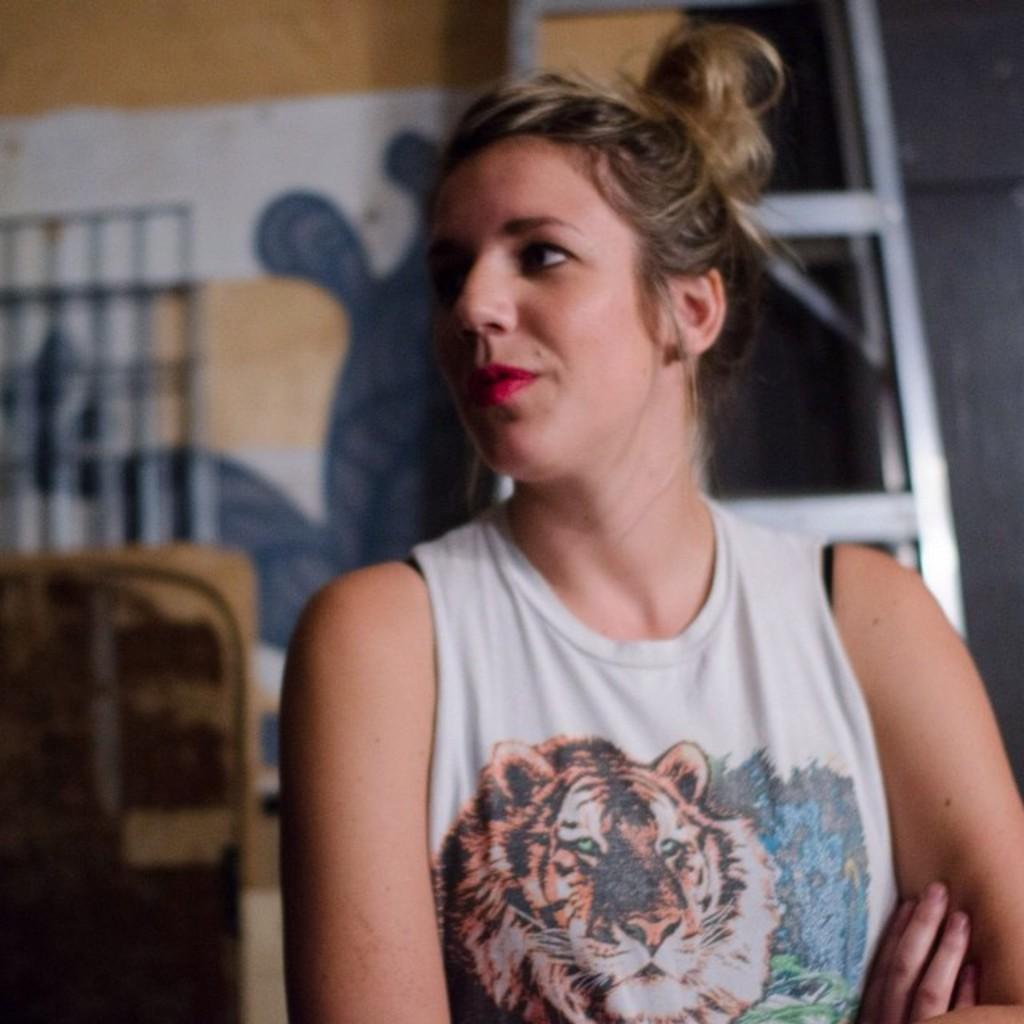Who is present in the image? There is a woman in the image. What is the woman wearing? The woman is wearing a white dress. Can you describe the background of the image? The background of the image is blurry, but a wall and a ladder are visible. Are there any other objects in the background? Yes, there are other unspecified objects in the background. What type of collar is the woman wearing in the image? The image does not show any collar on the woman's dress, as she is wearing a white dress without any visible collar. 